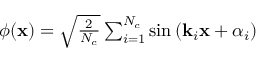<formula> <loc_0><loc_0><loc_500><loc_500>\begin{array} { r } { \phi ( x ) = \sqrt { \frac { 2 } { N _ { c } } } \sum _ { i = 1 } ^ { N _ { c } } \sin \left ( k _ { i } x + \alpha _ { i } \right ) } \end{array}</formula> 